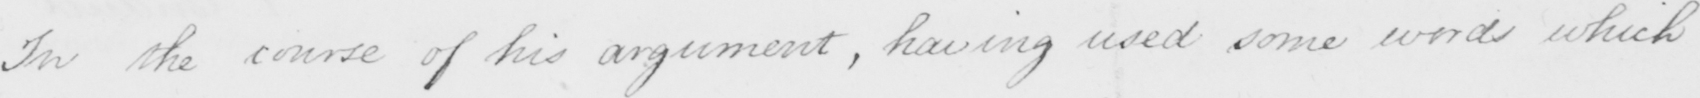Please transcribe the handwritten text in this image. For the course of his argument , having used some words which 